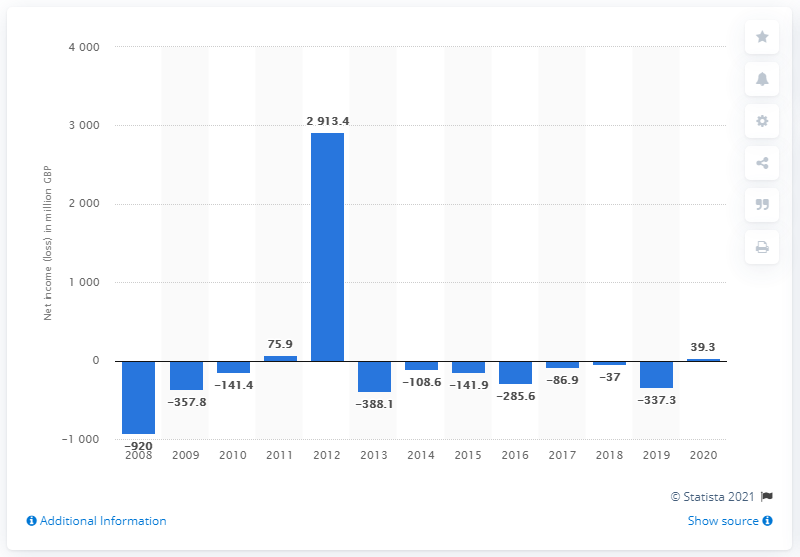Draw attention to some important aspects in this diagram. In 2019, Virgin Media saw a slight increase in revenues from its fixed-line and residential networks. Virgin Media reported a net income of 39.3 million in the first quarter of this year, which is the company's highest net income since 2012. 